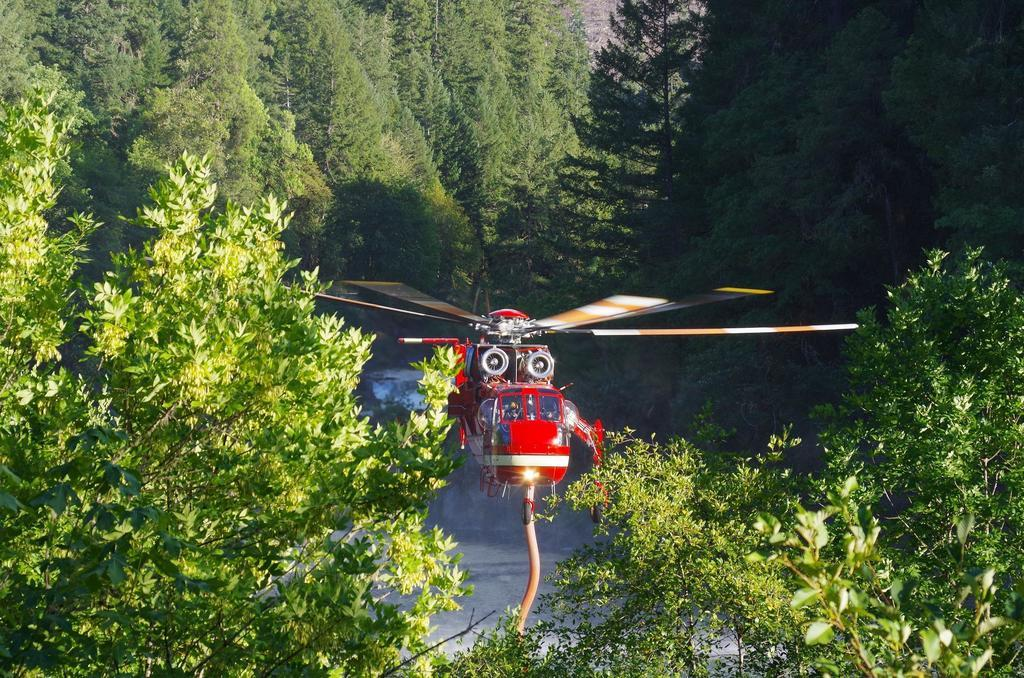What type of vehicle is in the image? There is a red helicopter in the image. Where is the helicopter located? The helicopter is in the air. What can be seen around the helicopter? Trees are present around the helicopter. What is in the middle of the trees? There is water in the middle of the trees. Can you touch the helicopter in the image? No, you cannot touch the helicopter in the image, as it is a two-dimensional representation and not a physical object. 